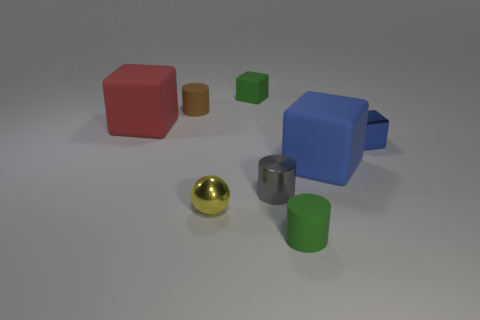There is a large red rubber object to the left of the tiny gray shiny object; is it the same shape as the tiny green matte object that is in front of the large red object?
Your answer should be compact. No. How many objects are purple metal cylinders or rubber cylinders?
Give a very brief answer. 2. What is the size of the red thing that is the same shape as the big blue rubber object?
Ensure brevity in your answer.  Large. Are there more small metal spheres in front of the small gray object than small cyan objects?
Offer a terse response. Yes. Does the red cube have the same material as the small brown object?
Your answer should be compact. Yes. How many objects are small matte objects in front of the gray thing or large matte cubes that are in front of the blue metallic block?
Ensure brevity in your answer.  2. There is a tiny matte thing that is the same shape as the large blue rubber thing; what is its color?
Provide a short and direct response. Green. How many large objects have the same color as the metallic block?
Provide a short and direct response. 1. How many things are either green rubber objects on the right side of the gray shiny object or tiny cylinders?
Make the answer very short. 3. What color is the large matte block on the right side of the tiny brown rubber cylinder behind the large rubber cube on the left side of the green cylinder?
Provide a short and direct response. Blue. 